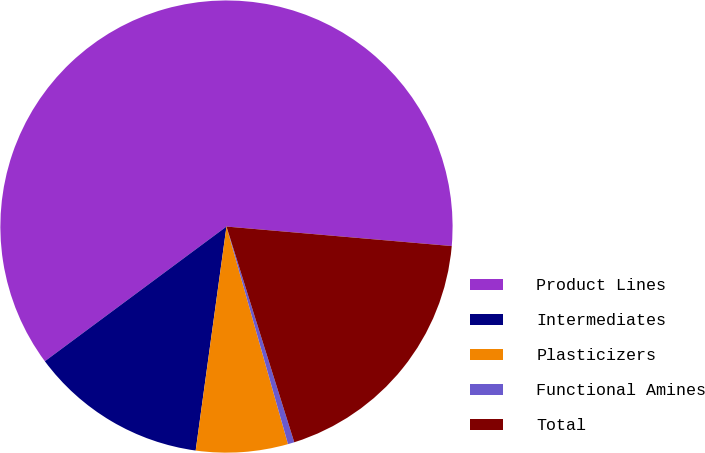<chart> <loc_0><loc_0><loc_500><loc_500><pie_chart><fcel>Product Lines<fcel>Intermediates<fcel>Plasticizers<fcel>Functional Amines<fcel>Total<nl><fcel>61.53%<fcel>12.67%<fcel>6.56%<fcel>0.46%<fcel>18.78%<nl></chart> 